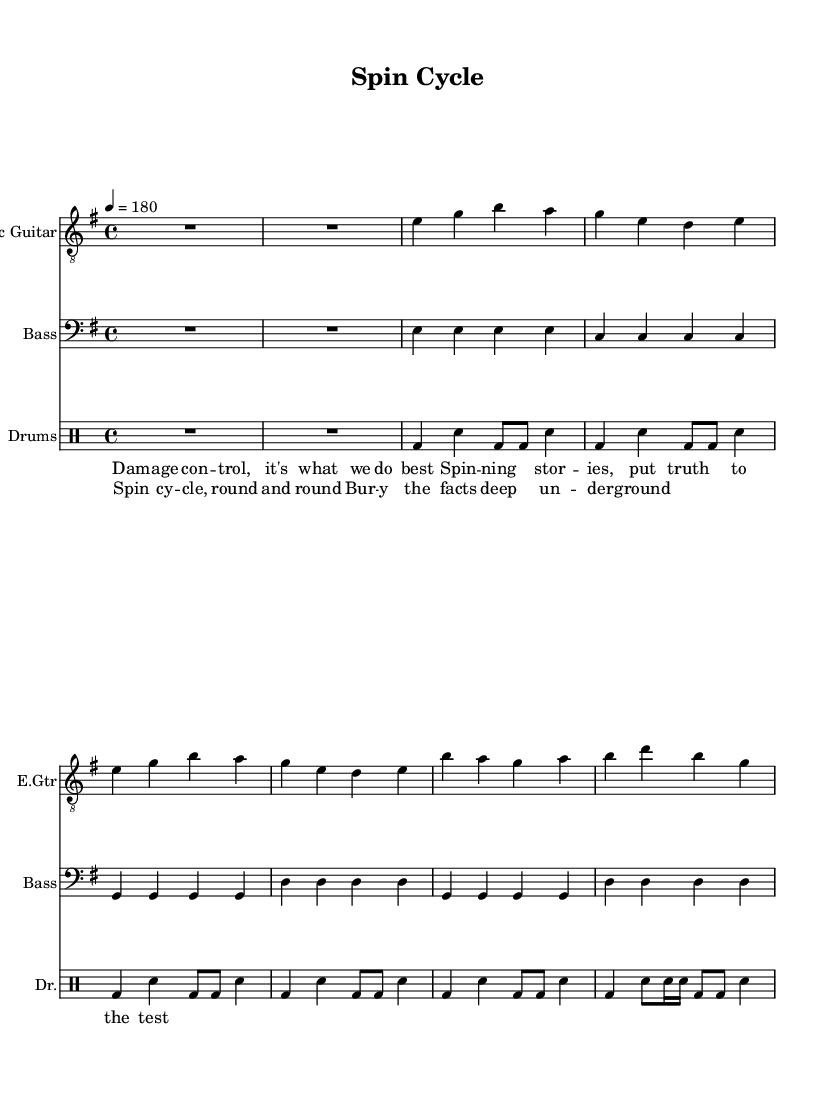What is the key signature of this music? The key signature is indicated at the beginning of the piece. It shows one sharp, which corresponds to E minor.
Answer: E minor What is the time signature of this music? The time signature is found at the beginning of the score. It indicates that there are four beats in every measure.
Answer: 4/4 What is the tempo marking for the song? The tempo marking is located at the beginning of the score, showing that the music should be played at a speed of 180 beats per minute.
Answer: 180 How many measures are in the electric guitar part? To determine the number of measures, count the sections in the electric guitar staff; each distinct line separated by a bar line counts as one measure. There are six measures in total.
Answer: 6 What is the primary theme of the lyrics? The lyrics focus on media influence and techniques of damage control related to public relations strategies, which is evident from their wording that references "damage control" and "spinning stories."
Answer: Media spin What instrument has the rhythmic motif mimicking the bass drum? The drum staff displays the notations, and the bass drum is indicated with a specific symbol for the bass notes throughout the entire song, playing consistently in each measure.
Answer: Drums How would you describe the overall style of this composition? The song features fast-paced rhythms, aggressive strumming, and lyrical themes typical of punk rock, which is characterized by its tempo and subject matter that critiques societal issues.
Answer: Punk rock 